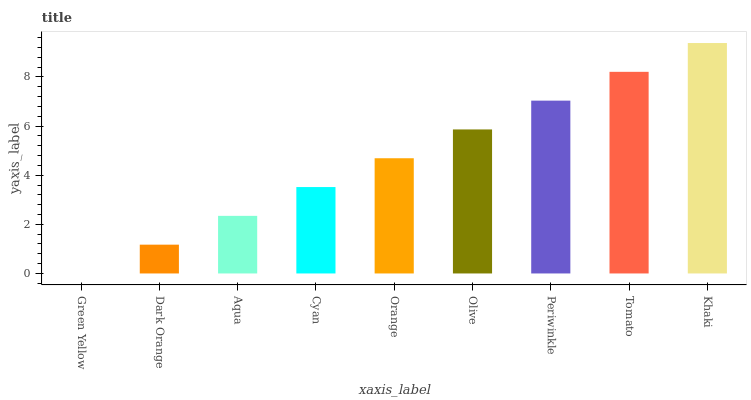Is Green Yellow the minimum?
Answer yes or no. Yes. Is Khaki the maximum?
Answer yes or no. Yes. Is Dark Orange the minimum?
Answer yes or no. No. Is Dark Orange the maximum?
Answer yes or no. No. Is Dark Orange greater than Green Yellow?
Answer yes or no. Yes. Is Green Yellow less than Dark Orange?
Answer yes or no. Yes. Is Green Yellow greater than Dark Orange?
Answer yes or no. No. Is Dark Orange less than Green Yellow?
Answer yes or no. No. Is Orange the high median?
Answer yes or no. Yes. Is Orange the low median?
Answer yes or no. Yes. Is Dark Orange the high median?
Answer yes or no. No. Is Dark Orange the low median?
Answer yes or no. No. 